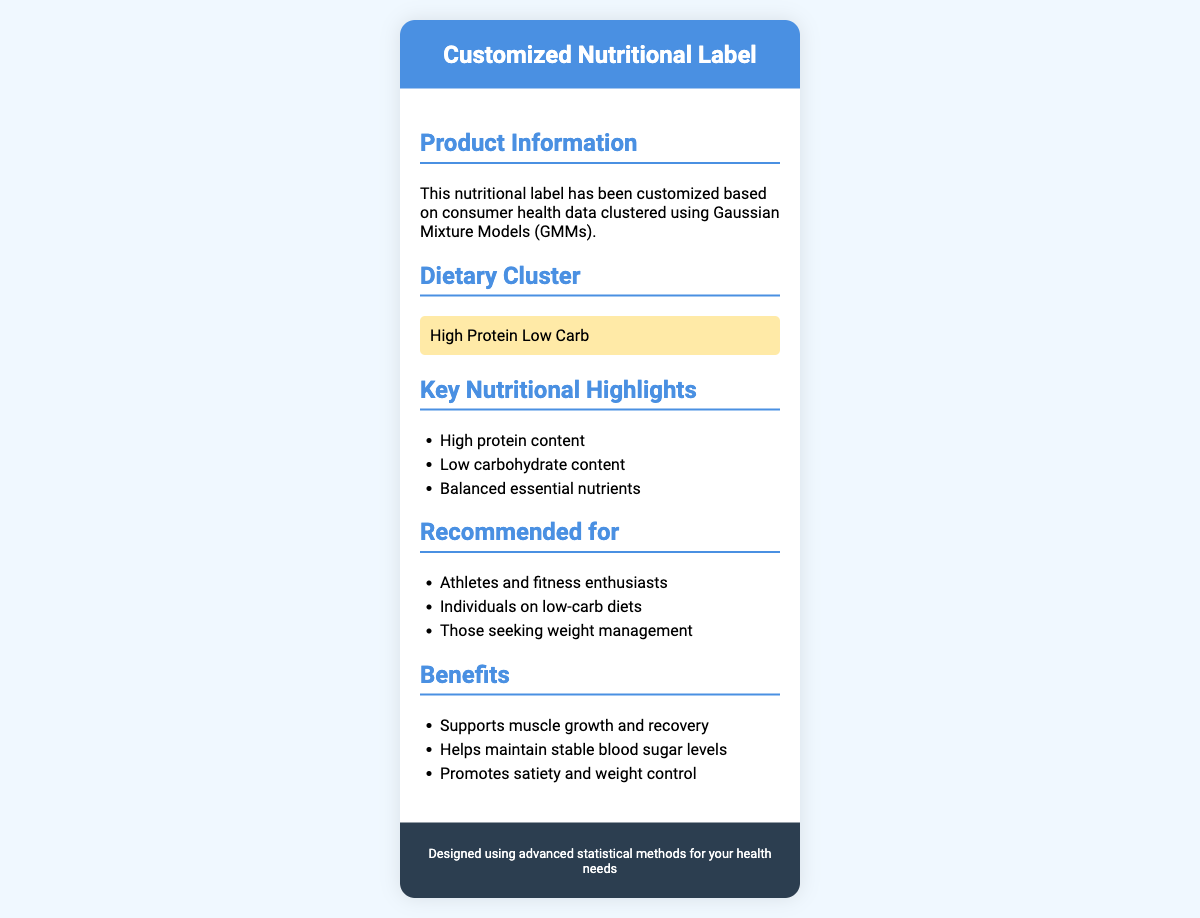What dietary cluster is highlighted? The document emphasizes the 'High Protein Low Carb' dietary cluster.
Answer: High Protein Low Carb Who is the nutritional label recommended for? The document lists several groups such as athletes and individuals on low-carb diets as the target audience.
Answer: Athletes and fitness enthusiasts What key nutritional highlight emphasizes protein? The document specifically mentions the high protein content as a key highlight.
Answer: High protein content What is one of the benefits listed? The document outlines several benefits, including support for muscle growth and recovery.
Answer: Supports muscle growth and recovery How many key nutritional highlights are listed? There are three key nutritional highlights mentioned in the document.
Answer: Three 